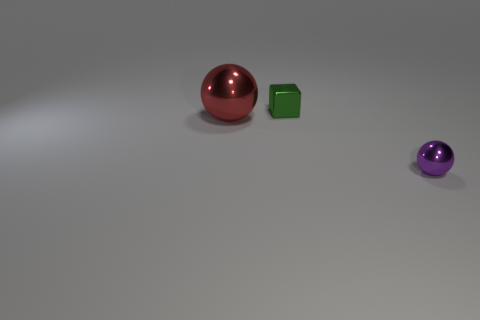Add 1 tiny yellow cylinders. How many objects exist? 4 Subtract all blocks. How many objects are left? 2 Subtract 1 cubes. How many cubes are left? 0 Subtract all brown spheres. Subtract all cyan cubes. How many spheres are left? 2 Subtract all gray cylinders. How many green spheres are left? 0 Subtract all spheres. Subtract all large purple matte cylinders. How many objects are left? 1 Add 3 green cubes. How many green cubes are left? 4 Add 3 big balls. How many big balls exist? 4 Subtract 0 cyan cubes. How many objects are left? 3 